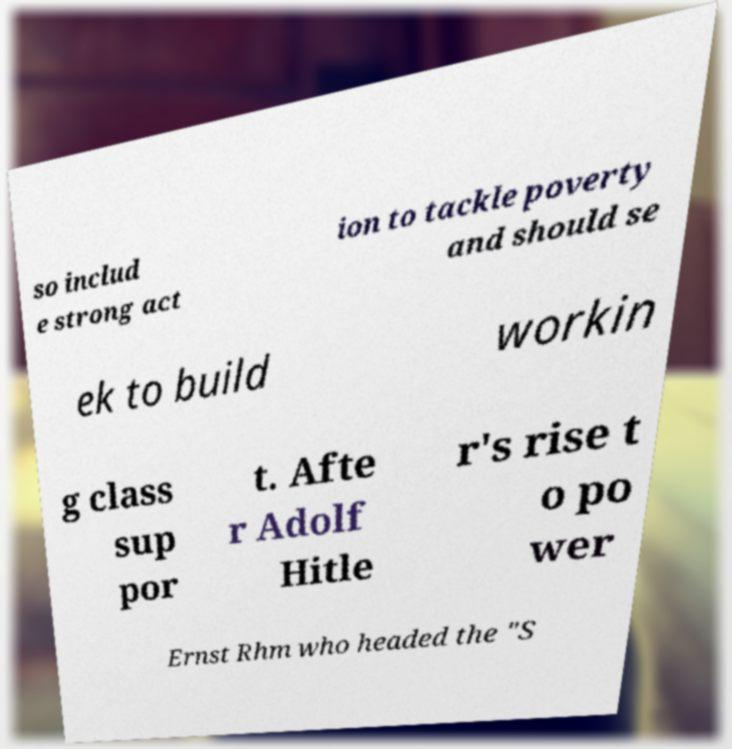Please read and relay the text visible in this image. What does it say? so includ e strong act ion to tackle poverty and should se ek to build workin g class sup por t. Afte r Adolf Hitle r's rise t o po wer Ernst Rhm who headed the "S 